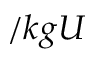<formula> <loc_0><loc_0><loc_500><loc_500>/ k g U</formula> 